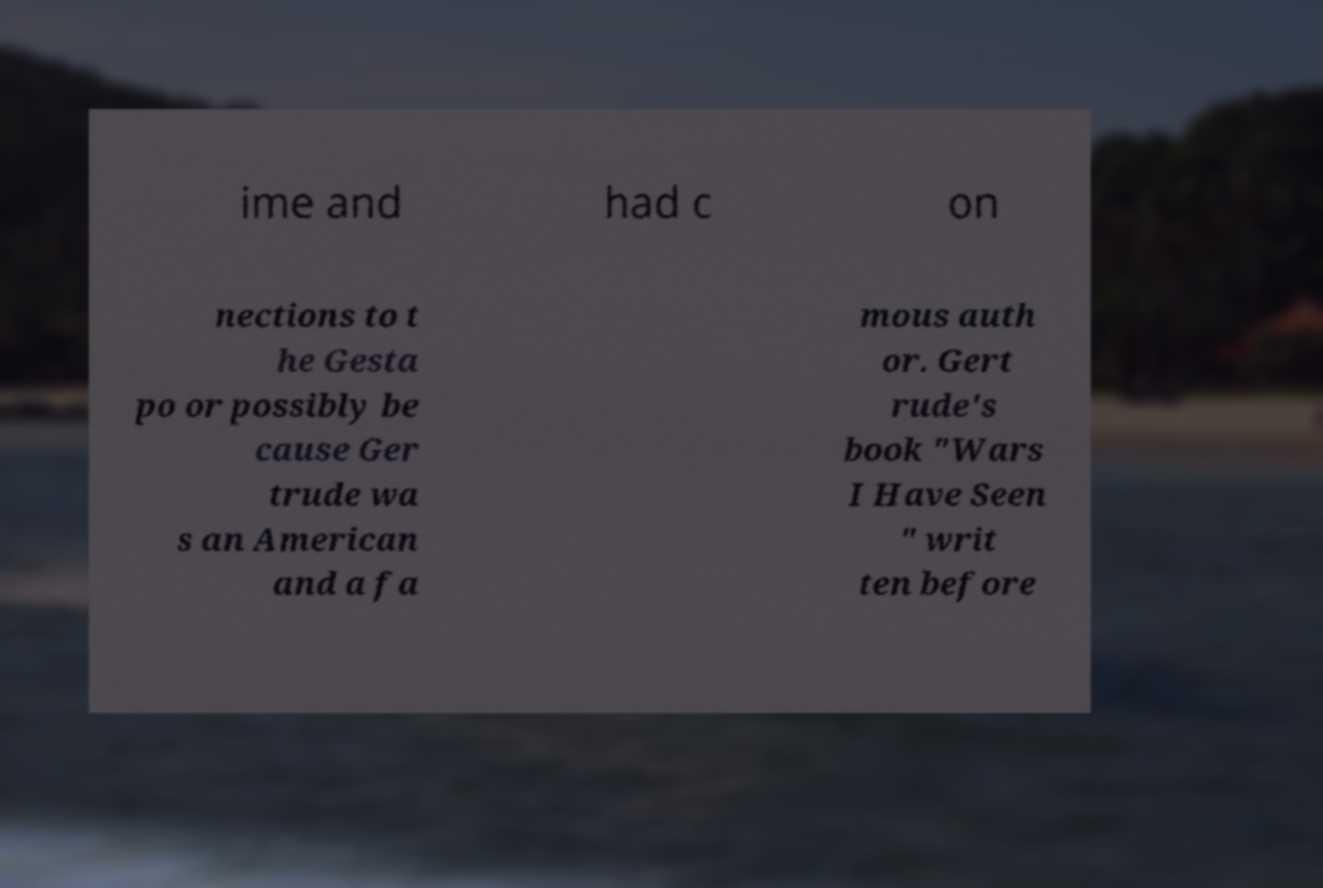Could you extract and type out the text from this image? ime and had c on nections to t he Gesta po or possibly be cause Ger trude wa s an American and a fa mous auth or. Gert rude's book "Wars I Have Seen " writ ten before 